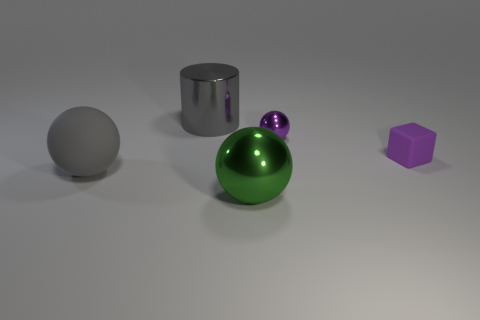There is a cylinder; is it the same size as the metal object that is in front of the purple shiny object? The cylinder appears to be larger in both height and diameter compared to the small metallic sphere located in front of the purple cube. When comparing size, it's useful to consider both dimensions to get a clear perspective. 